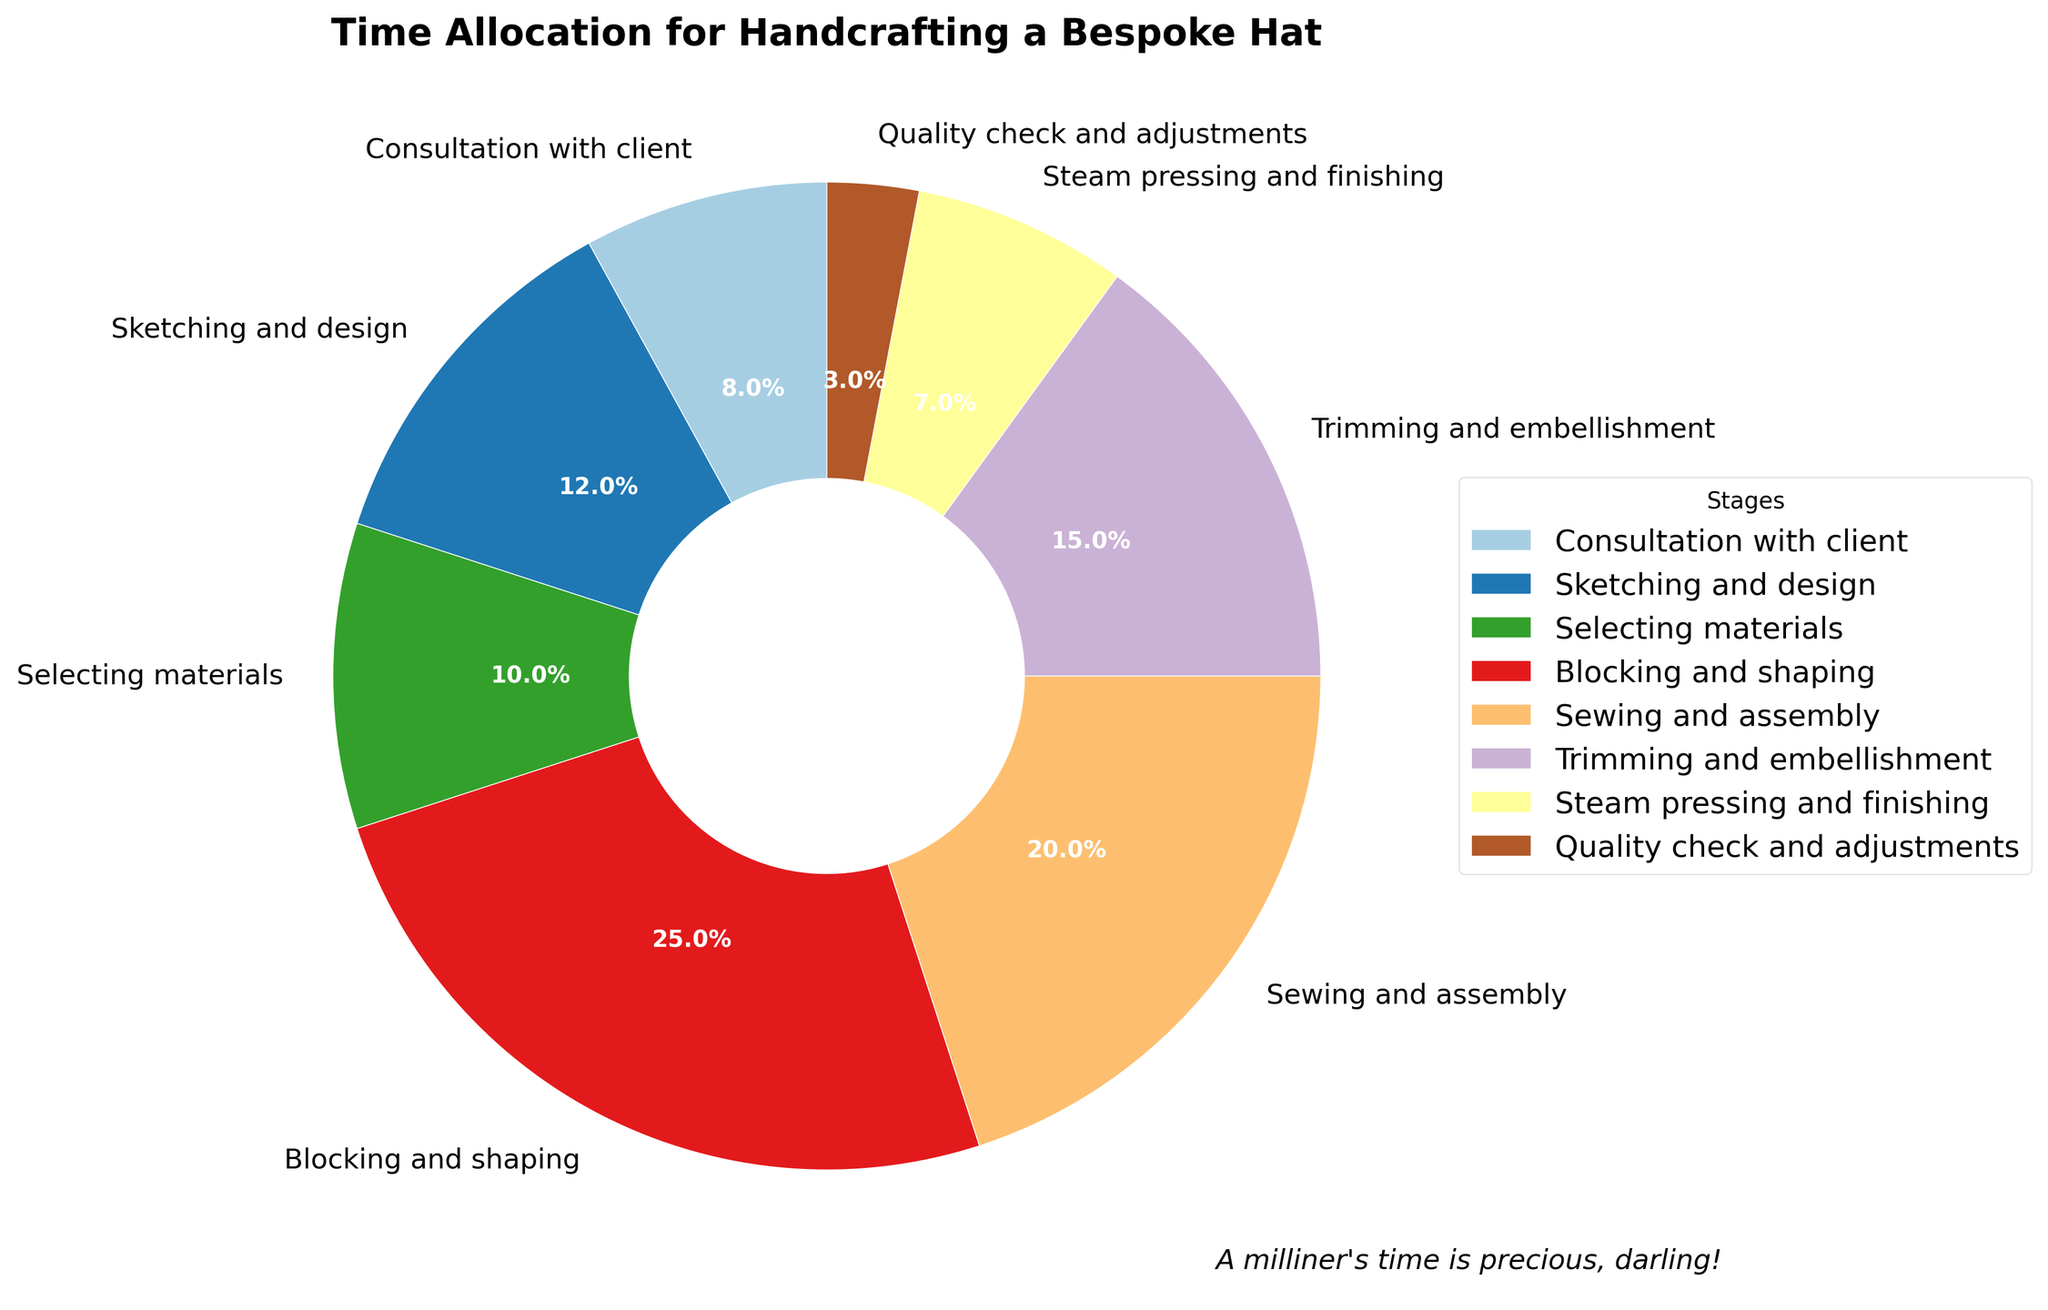How much time is spent on sketching and design compared to trimming and embellishment? First, find the percentage time allocation for "Sketching and design" (12%) and "Trimming and embellishment" (15%). Since 12% is less than 15%, "Sketching and design" takes less time.
Answer: 12% is less than 15% What is the total percentage of time spent on blocking and shaping, sewing and assembly, and trimming and embellishment? Add the time percentages for "Blocking and shaping" (25%), "Sewing and assembly" (20%), and "Trimming and embellishment" (15%). The total is 25 + 20 + 15 = 60%.
Answer: 60% Which stage takes the least amount of time and how much is it? Look for the stage with the smallest percentage in the pie chart. "Quality check and adjustments" has the smallest percentage at 3%.
Answer: Quality check and adjustments, 3% Does blocking and shaping take more time than the combined time for consultation with the client and sketching and design? Blocking and shaping takes 25%. Consultation with the client (8%) and sketching and design (12%) together take 8 + 12 = 20%. Since 25% is greater than 20%, blocking and shaping takes more time.
Answer: Yes What is the percentage difference between the time spent on selecting materials and steam pressing and finishing? The time spent on selecting materials is 10% and on steam pressing and finishing is 7%. The percentage difference is 10 - 7 = 3%.
Answer: 3% Between sewing and assembly and trimming and embellishment, which one takes more time and by how much? Sewing and assembly takes 20%, while trimming and embellishment takes 15%. The difference is 20 - 15 = 5%.
Answer: Sewing and assembly, 5% Summarize the time allocations for the initial consultations (consultation with client, sketching and design) versus the final stages (steam pressing and finishing, quality check and adjustments). The time for initial consultations is the sum of "Consultation with client" (8%) and "Sketching and design" (12%) which equals 8 + 12 = 20%. The final stages include "Steam pressing and finishing" (7%) and "Quality check and adjustments" (3%) summing up to 7 + 3 = 10%.
Answer: Initial consultations: 20%, Final stages: 10% What is the average time spent on the stages of selecting materials, trimming and embellishment, and steam pressing and finishing? Add the percentages and then divide by the number of stages. (10% + 15% + 7%) / 3 = 32 / 3 ≈ 10.67%.
Answer: 10.67% How much more time is spent on blocking and shaping compared to the combined time spent on steam pressing and finishing and quality check and adjustments? Blocking and shaping takes 25%. Steam pressing and finishing together with quality check and adjustments are 7% + 3% = 10%. Difference: 25 - 10 = 15%.
Answer: 15% Identify the chunk of the pie chart with the largest slice and name the corresponding stage. The largest slice in the pie chart is associated with "Blocking and shaping," which takes 25% of the time.
Answer: Blocking and shaping 